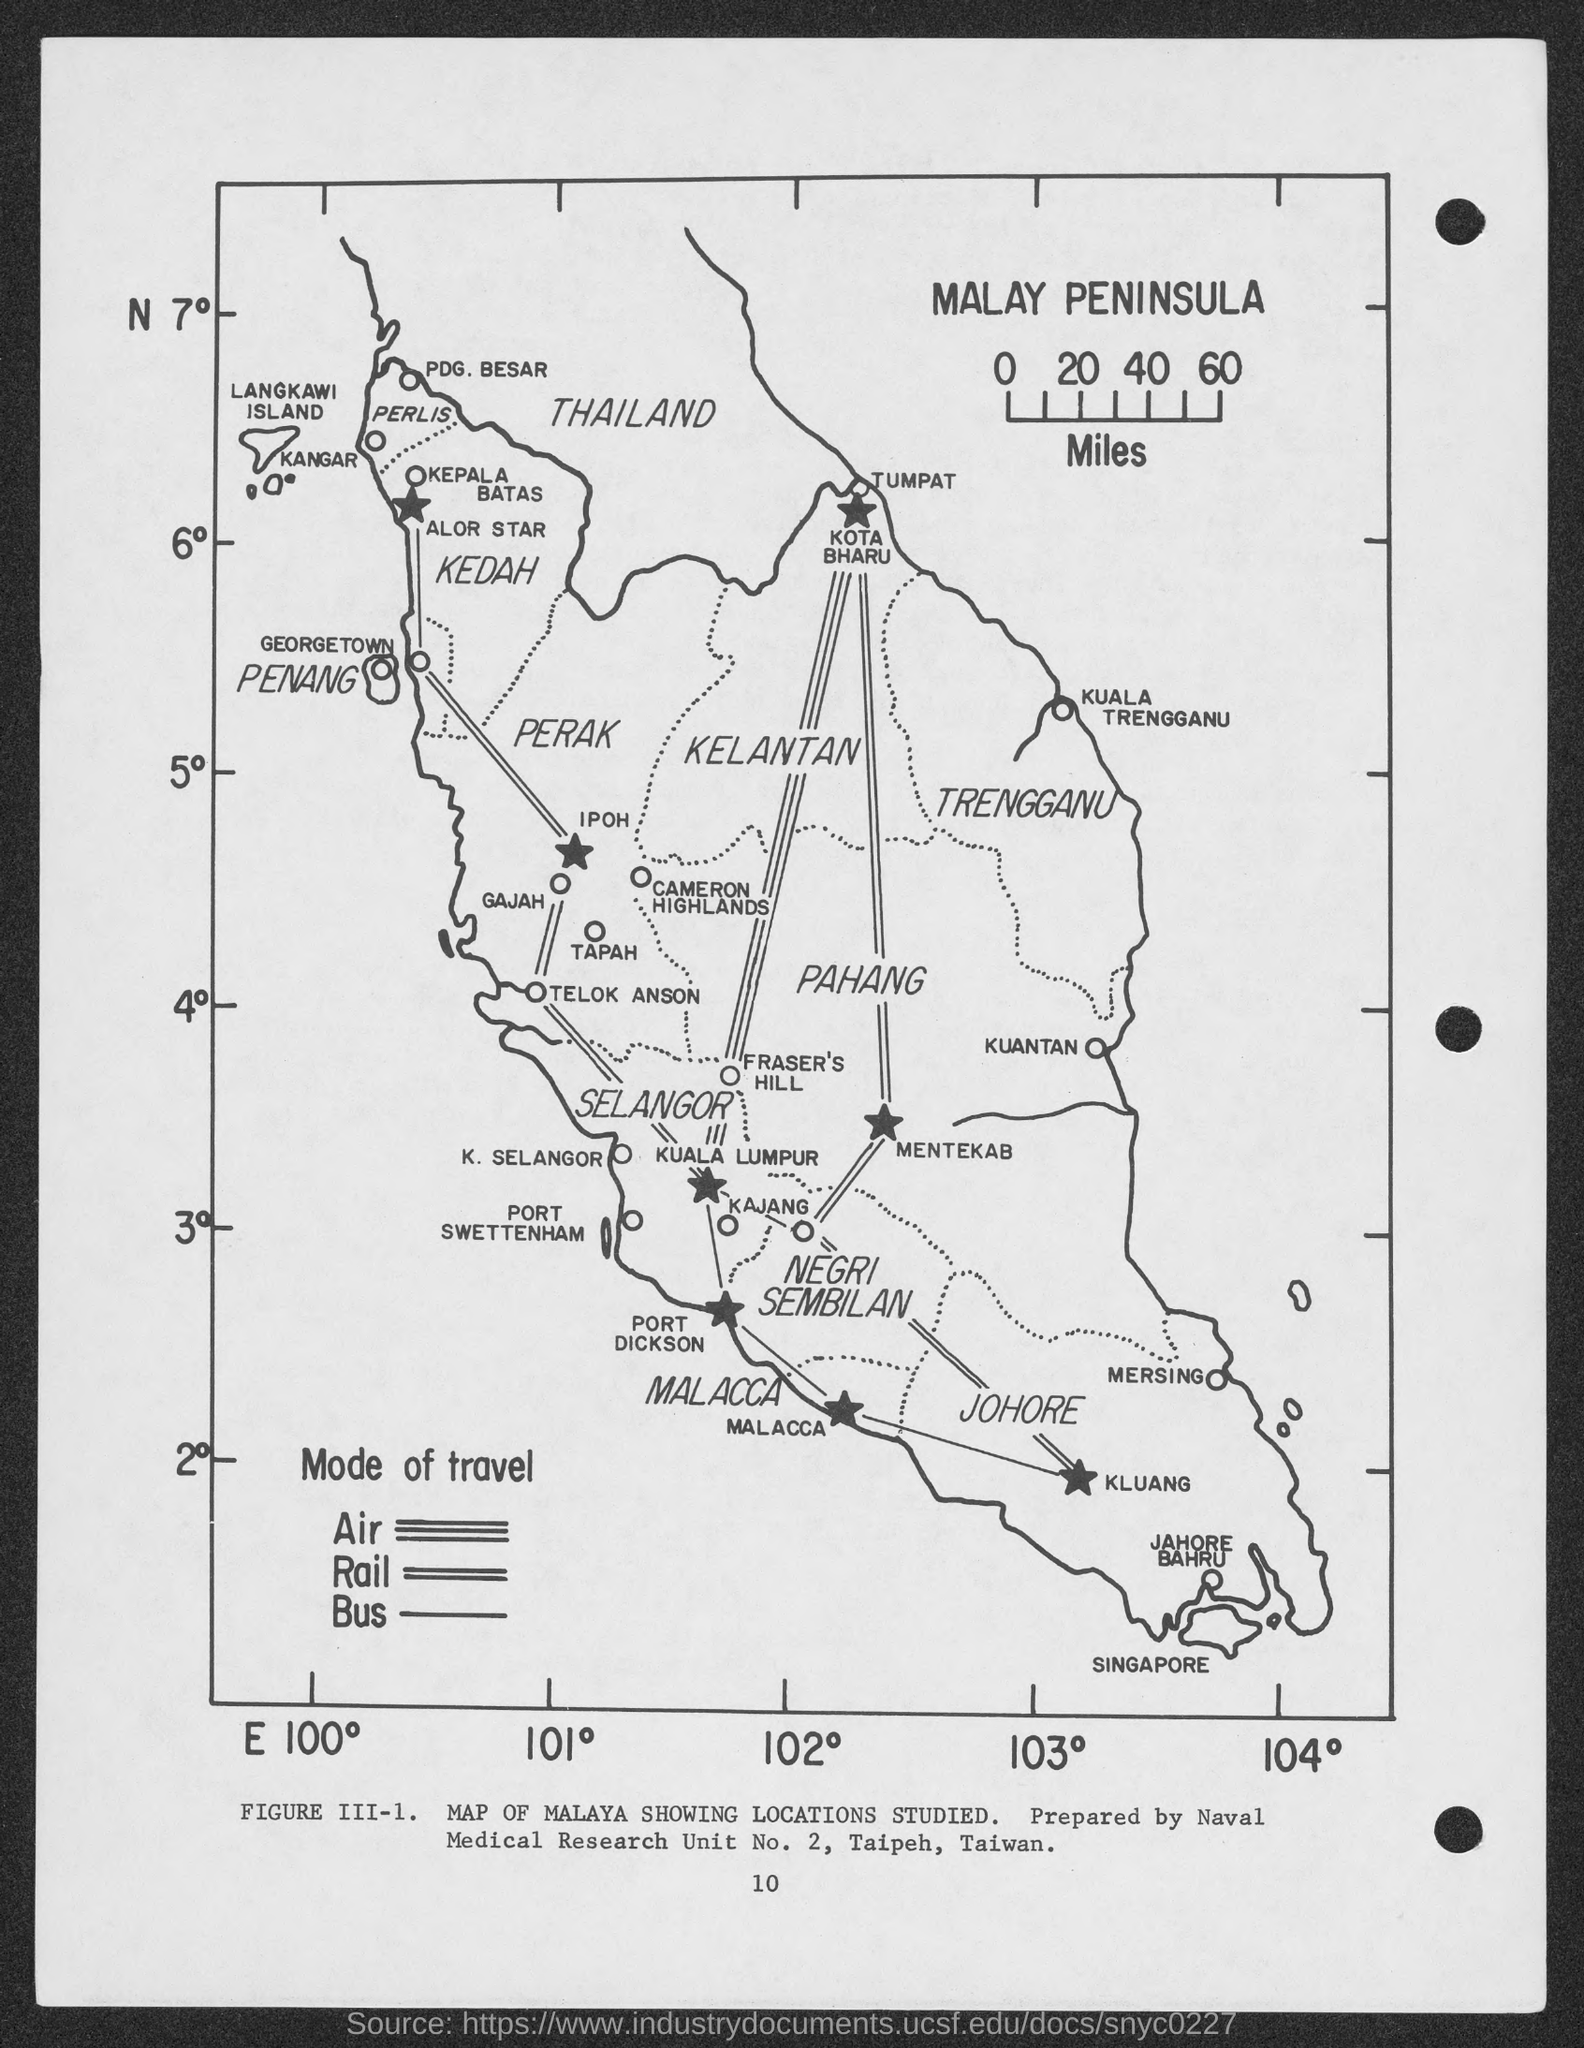List a handful of essential elements in this visual. The number at the bottom of the page is 10. 